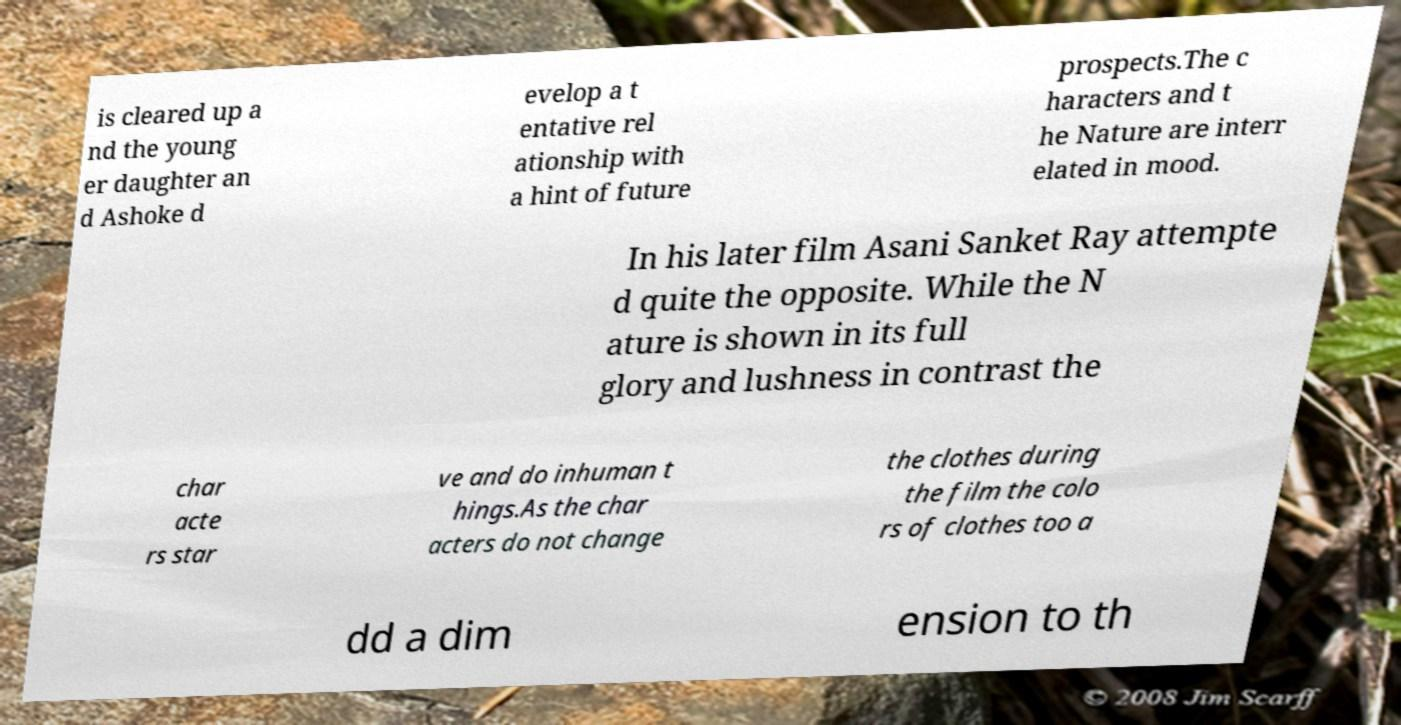Can you accurately transcribe the text from the provided image for me? is cleared up a nd the young er daughter an d Ashoke d evelop a t entative rel ationship with a hint of future prospects.The c haracters and t he Nature are interr elated in mood. In his later film Asani Sanket Ray attempte d quite the opposite. While the N ature is shown in its full glory and lushness in contrast the char acte rs star ve and do inhuman t hings.As the char acters do not change the clothes during the film the colo rs of clothes too a dd a dim ension to th 